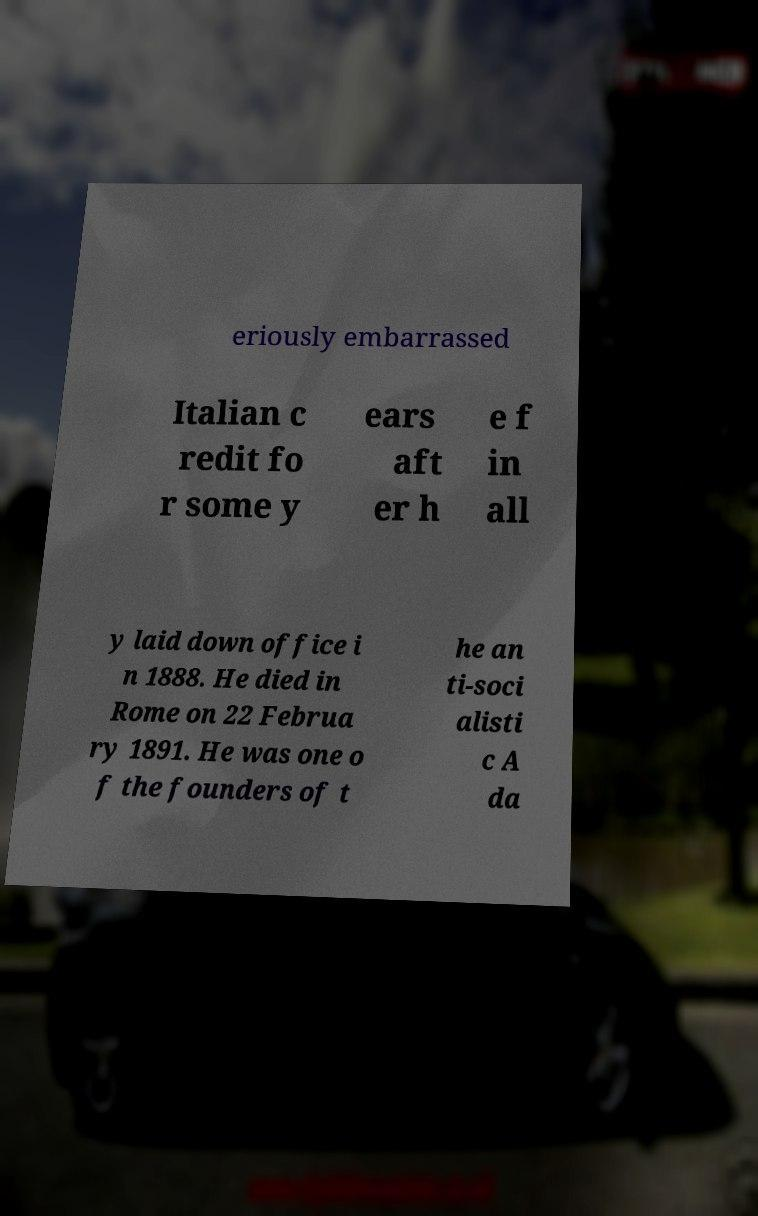Please identify and transcribe the text found in this image. eriously embarrassed Italian c redit fo r some y ears aft er h e f in all y laid down office i n 1888. He died in Rome on 22 Februa ry 1891. He was one o f the founders of t he an ti-soci alisti c A da 